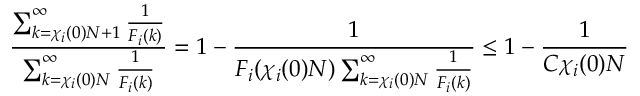<formula> <loc_0><loc_0><loc_500><loc_500>\frac { \sum _ { k = \chi _ { i } ( 0 ) N + 1 } ^ { \infty } \frac { 1 } { F _ { i } ( k ) } } { \sum _ { k = \chi _ { i } ( 0 ) N } ^ { \infty } \frac { 1 } { F _ { i } ( k ) } } = 1 - \frac { 1 } { F _ { i } ( \chi _ { i } ( 0 ) N ) \sum _ { k = \chi _ { i } ( 0 ) N } ^ { \infty } \frac { 1 } { F _ { i } ( k ) } } \leq 1 - \frac { 1 } { C \chi _ { i } ( 0 ) N }</formula> 